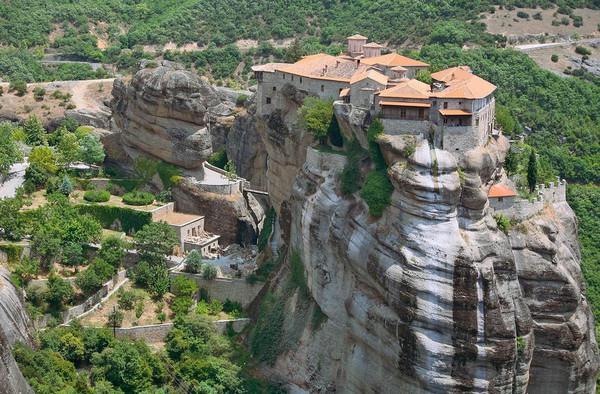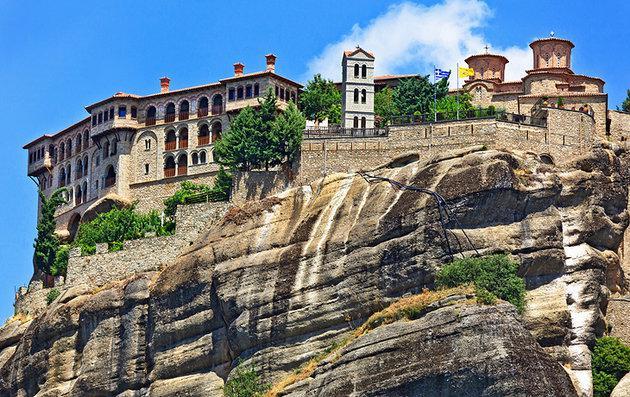The first image is the image on the left, the second image is the image on the right. For the images shown, is this caption "There are stairs in the image on the right" true? Answer yes or no. No. 